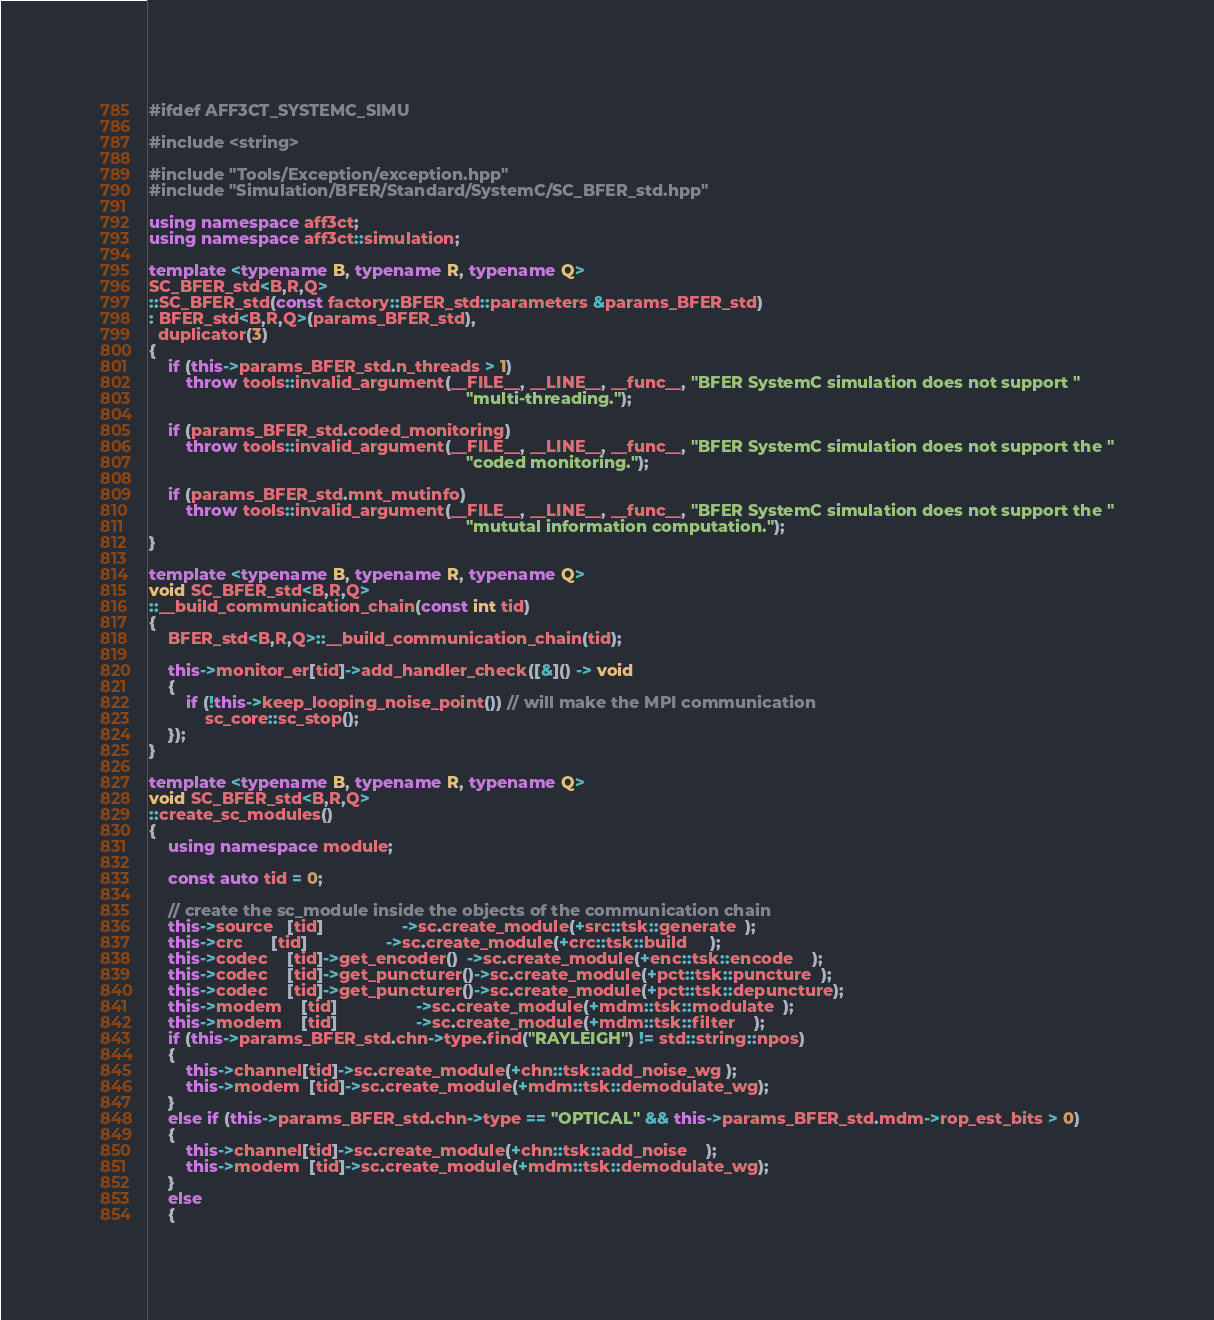<code> <loc_0><loc_0><loc_500><loc_500><_C++_>#ifdef AFF3CT_SYSTEMC_SIMU

#include <string>

#include "Tools/Exception/exception.hpp"
#include "Simulation/BFER/Standard/SystemC/SC_BFER_std.hpp"

using namespace aff3ct;
using namespace aff3ct::simulation;

template <typename B, typename R, typename Q>
SC_BFER_std<B,R,Q>
::SC_BFER_std(const factory::BFER_std::parameters &params_BFER_std)
: BFER_std<B,R,Q>(params_BFER_std),
  duplicator(3)
{
	if (this->params_BFER_std.n_threads > 1)
		throw tools::invalid_argument(__FILE__, __LINE__, __func__, "BFER SystemC simulation does not support "
		                                                            "multi-threading.");

	if (params_BFER_std.coded_monitoring)
		throw tools::invalid_argument(__FILE__, __LINE__, __func__, "BFER SystemC simulation does not support the "
		                                                            "coded monitoring.");

	if (params_BFER_std.mnt_mutinfo)
		throw tools::invalid_argument(__FILE__, __LINE__, __func__, "BFER SystemC simulation does not support the "
		                                                            "mututal information computation.");
}

template <typename B, typename R, typename Q>
void SC_BFER_std<B,R,Q>
::__build_communication_chain(const int tid)
{
	BFER_std<B,R,Q>::__build_communication_chain(tid);

	this->monitor_er[tid]->add_handler_check([&]() -> void
	{
		if (!this->keep_looping_noise_point()) // will make the MPI communication
			sc_core::sc_stop();
	});
}

template <typename B, typename R, typename Q>
void SC_BFER_std<B,R,Q>
::create_sc_modules()
{
	using namespace module;

	const auto tid = 0;

	// create the sc_module inside the objects of the communication chain
	this->source   [tid]                 ->sc.create_module(+src::tsk::generate  );
	this->crc      [tid]                 ->sc.create_module(+crc::tsk::build     );
	this->codec    [tid]->get_encoder()  ->sc.create_module(+enc::tsk::encode    );
	this->codec    [tid]->get_puncturer()->sc.create_module(+pct::tsk::puncture  );
	this->codec    [tid]->get_puncturer()->sc.create_module(+pct::tsk::depuncture);
	this->modem    [tid]                 ->sc.create_module(+mdm::tsk::modulate  );
	this->modem    [tid]                 ->sc.create_module(+mdm::tsk::filter    );
	if (this->params_BFER_std.chn->type.find("RAYLEIGH") != std::string::npos)
	{
		this->channel[tid]->sc.create_module(+chn::tsk::add_noise_wg );
		this->modem  [tid]->sc.create_module(+mdm::tsk::demodulate_wg);
	}
	else if (this->params_BFER_std.chn->type == "OPTICAL" && this->params_BFER_std.mdm->rop_est_bits > 0)
	{
		this->channel[tid]->sc.create_module(+chn::tsk::add_noise    );
		this->modem  [tid]->sc.create_module(+mdm::tsk::demodulate_wg);
	}
	else
	{</code> 